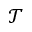<formula> <loc_0><loc_0><loc_500><loc_500>\mathcal { T }</formula> 